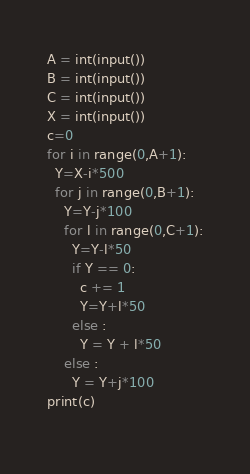<code> <loc_0><loc_0><loc_500><loc_500><_Python_>A = int(input())
B = int(input())
C = int(input())
X = int(input())
c=0
for i in range(0,A+1):
  Y=X-i*500
  for j in range(0,B+1):
    Y=Y-j*100
    for l in range(0,C+1):
      Y=Y-l*50
      if Y == 0:
        c += 1
        Y=Y+l*50
      else :
        Y = Y + l*50
    else :
      Y = Y+j*100
print(c)
  

</code> 